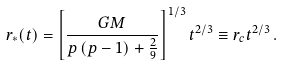Convert formula to latex. <formula><loc_0><loc_0><loc_500><loc_500>r _ { * } ( t ) = \left [ \frac { G M } { p \left ( p - 1 \right ) + \frac { 2 } { 9 } } \right ] ^ { 1 / 3 } t ^ { 2 / 3 } \equiv r _ { c } t ^ { 2 / 3 } \, .</formula> 